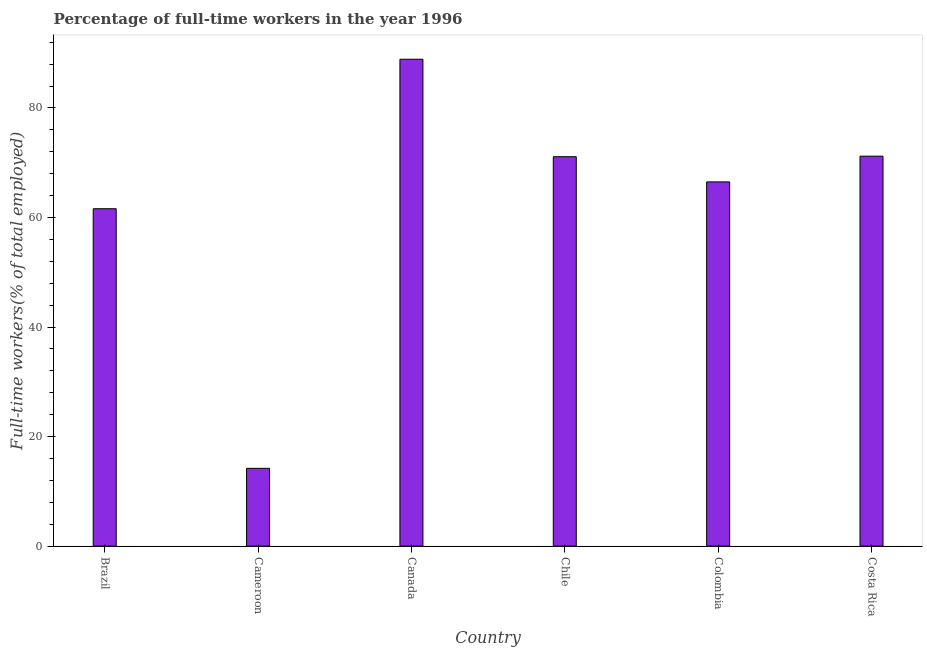Does the graph contain any zero values?
Your response must be concise. No. Does the graph contain grids?
Make the answer very short. No. What is the title of the graph?
Offer a terse response. Percentage of full-time workers in the year 1996. What is the label or title of the X-axis?
Offer a terse response. Country. What is the label or title of the Y-axis?
Offer a very short reply. Full-time workers(% of total employed). What is the percentage of full-time workers in Canada?
Offer a very short reply. 88.9. Across all countries, what is the maximum percentage of full-time workers?
Give a very brief answer. 88.9. Across all countries, what is the minimum percentage of full-time workers?
Offer a terse response. 14.2. In which country was the percentage of full-time workers maximum?
Your answer should be compact. Canada. In which country was the percentage of full-time workers minimum?
Your answer should be compact. Cameroon. What is the sum of the percentage of full-time workers?
Your answer should be very brief. 373.5. What is the difference between the percentage of full-time workers in Colombia and Costa Rica?
Provide a short and direct response. -4.7. What is the average percentage of full-time workers per country?
Your response must be concise. 62.25. What is the median percentage of full-time workers?
Give a very brief answer. 68.8. What is the ratio of the percentage of full-time workers in Brazil to that in Cameroon?
Ensure brevity in your answer.  4.34. Is the percentage of full-time workers in Canada less than that in Colombia?
Offer a terse response. No. Is the sum of the percentage of full-time workers in Brazil and Costa Rica greater than the maximum percentage of full-time workers across all countries?
Your answer should be very brief. Yes. What is the difference between the highest and the lowest percentage of full-time workers?
Offer a very short reply. 74.7. How many countries are there in the graph?
Keep it short and to the point. 6. What is the difference between two consecutive major ticks on the Y-axis?
Provide a short and direct response. 20. Are the values on the major ticks of Y-axis written in scientific E-notation?
Your answer should be very brief. No. What is the Full-time workers(% of total employed) in Brazil?
Your answer should be compact. 61.6. What is the Full-time workers(% of total employed) of Cameroon?
Keep it short and to the point. 14.2. What is the Full-time workers(% of total employed) of Canada?
Give a very brief answer. 88.9. What is the Full-time workers(% of total employed) in Chile?
Your answer should be compact. 71.1. What is the Full-time workers(% of total employed) in Colombia?
Provide a short and direct response. 66.5. What is the Full-time workers(% of total employed) of Costa Rica?
Your answer should be compact. 71.2. What is the difference between the Full-time workers(% of total employed) in Brazil and Cameroon?
Ensure brevity in your answer.  47.4. What is the difference between the Full-time workers(% of total employed) in Brazil and Canada?
Offer a very short reply. -27.3. What is the difference between the Full-time workers(% of total employed) in Brazil and Chile?
Offer a very short reply. -9.5. What is the difference between the Full-time workers(% of total employed) in Cameroon and Canada?
Offer a very short reply. -74.7. What is the difference between the Full-time workers(% of total employed) in Cameroon and Chile?
Your answer should be very brief. -56.9. What is the difference between the Full-time workers(% of total employed) in Cameroon and Colombia?
Give a very brief answer. -52.3. What is the difference between the Full-time workers(% of total employed) in Cameroon and Costa Rica?
Provide a short and direct response. -57. What is the difference between the Full-time workers(% of total employed) in Canada and Colombia?
Your answer should be compact. 22.4. What is the difference between the Full-time workers(% of total employed) in Chile and Colombia?
Your answer should be compact. 4.6. What is the difference between the Full-time workers(% of total employed) in Chile and Costa Rica?
Offer a terse response. -0.1. What is the ratio of the Full-time workers(% of total employed) in Brazil to that in Cameroon?
Offer a very short reply. 4.34. What is the ratio of the Full-time workers(% of total employed) in Brazil to that in Canada?
Make the answer very short. 0.69. What is the ratio of the Full-time workers(% of total employed) in Brazil to that in Chile?
Give a very brief answer. 0.87. What is the ratio of the Full-time workers(% of total employed) in Brazil to that in Colombia?
Offer a terse response. 0.93. What is the ratio of the Full-time workers(% of total employed) in Brazil to that in Costa Rica?
Make the answer very short. 0.86. What is the ratio of the Full-time workers(% of total employed) in Cameroon to that in Canada?
Ensure brevity in your answer.  0.16. What is the ratio of the Full-time workers(% of total employed) in Cameroon to that in Colombia?
Make the answer very short. 0.21. What is the ratio of the Full-time workers(% of total employed) in Cameroon to that in Costa Rica?
Offer a terse response. 0.2. What is the ratio of the Full-time workers(% of total employed) in Canada to that in Colombia?
Provide a succinct answer. 1.34. What is the ratio of the Full-time workers(% of total employed) in Canada to that in Costa Rica?
Keep it short and to the point. 1.25. What is the ratio of the Full-time workers(% of total employed) in Chile to that in Colombia?
Your answer should be compact. 1.07. What is the ratio of the Full-time workers(% of total employed) in Chile to that in Costa Rica?
Make the answer very short. 1. What is the ratio of the Full-time workers(% of total employed) in Colombia to that in Costa Rica?
Give a very brief answer. 0.93. 